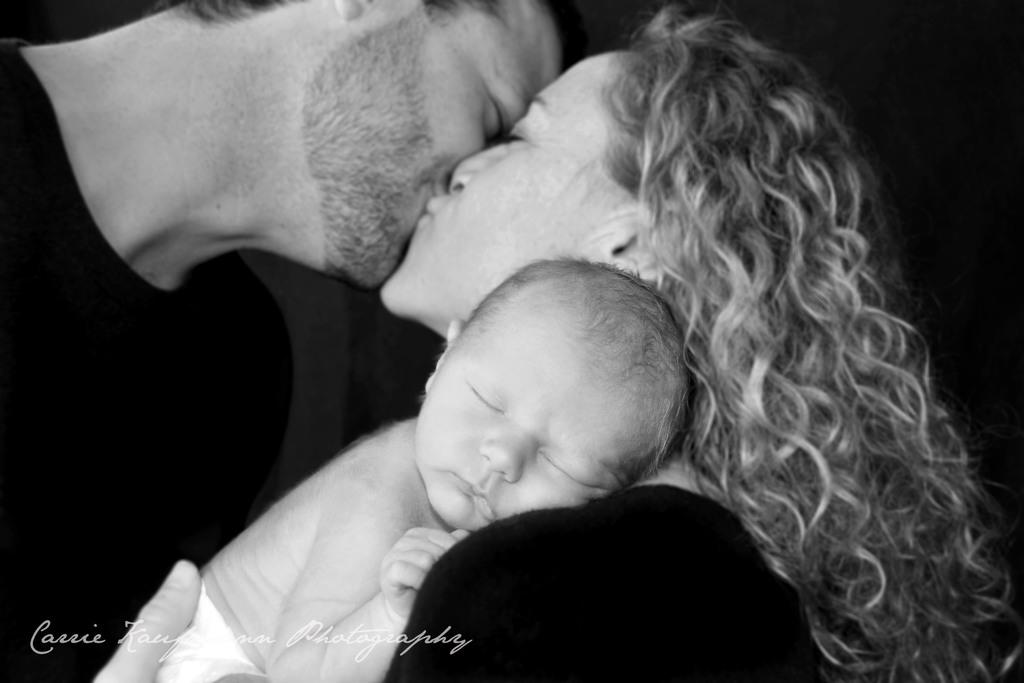What is the color scheme of the image? The image is black and white. What are the two people in the image doing? The two people are kissing each other in the image. Can you describe the woman's action in the image? The woman is holding a baby in the image. Is there any text or logo visible in the image? Yes, there is a watermark in the bottom left of the image. What type of sea creature can be seen swimming in the image? There is no sea creature present in the image; it is a black and white image of two people kissing and a woman holding a baby. What type of board is visible in the image? There is no board present in the image. 